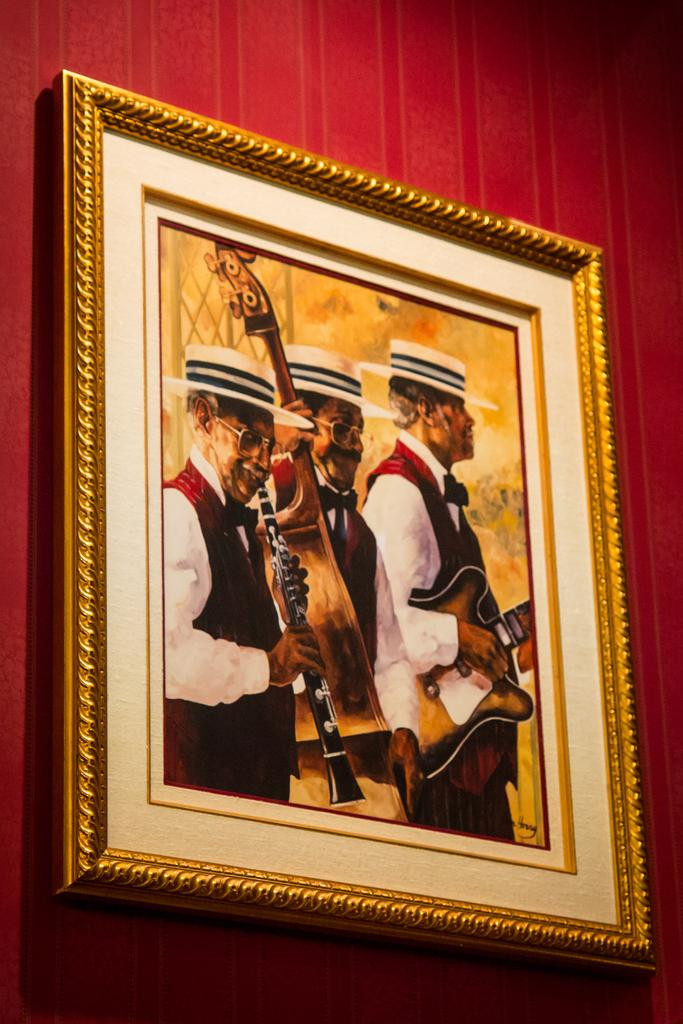What object is attached to the wall in the image? There is a photo frame in the image, and it is attached to a wall. What is displayed within the photo frame? The photo frame contains a picture of three persons. What are the three persons wearing in the picture? The three persons are wearing white hats in the picture. What are the three persons doing in the picture? The three persons are playing musical instruments in the picture. What type of sweater is the person on the edge of the image wearing? There is no person wearing a sweater on the edge of the image, as the image only contains a photo frame with a picture of three persons. 